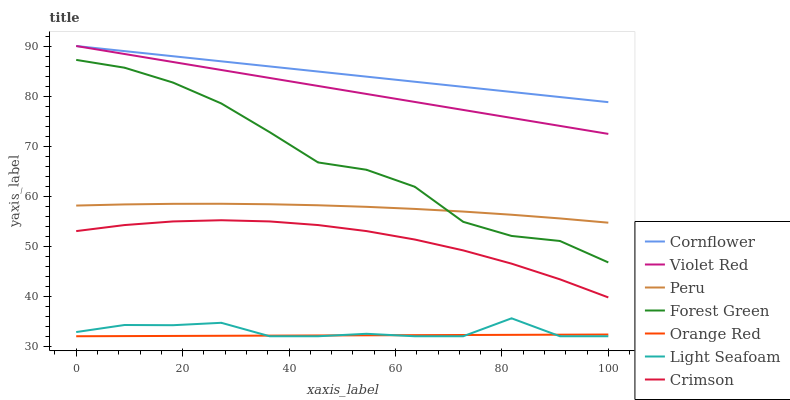Does Orange Red have the minimum area under the curve?
Answer yes or no. Yes. Does Cornflower have the maximum area under the curve?
Answer yes or no. Yes. Does Violet Red have the minimum area under the curve?
Answer yes or no. No. Does Violet Red have the maximum area under the curve?
Answer yes or no. No. Is Violet Red the smoothest?
Answer yes or no. Yes. Is Light Seafoam the roughest?
Answer yes or no. Yes. Is Forest Green the smoothest?
Answer yes or no. No. Is Forest Green the roughest?
Answer yes or no. No. Does Light Seafoam have the lowest value?
Answer yes or no. Yes. Does Violet Red have the lowest value?
Answer yes or no. No. Does Violet Red have the highest value?
Answer yes or no. Yes. Does Forest Green have the highest value?
Answer yes or no. No. Is Light Seafoam less than Forest Green?
Answer yes or no. Yes. Is Violet Red greater than Light Seafoam?
Answer yes or no. Yes. Does Peru intersect Forest Green?
Answer yes or no. Yes. Is Peru less than Forest Green?
Answer yes or no. No. Is Peru greater than Forest Green?
Answer yes or no. No. Does Light Seafoam intersect Forest Green?
Answer yes or no. No. 